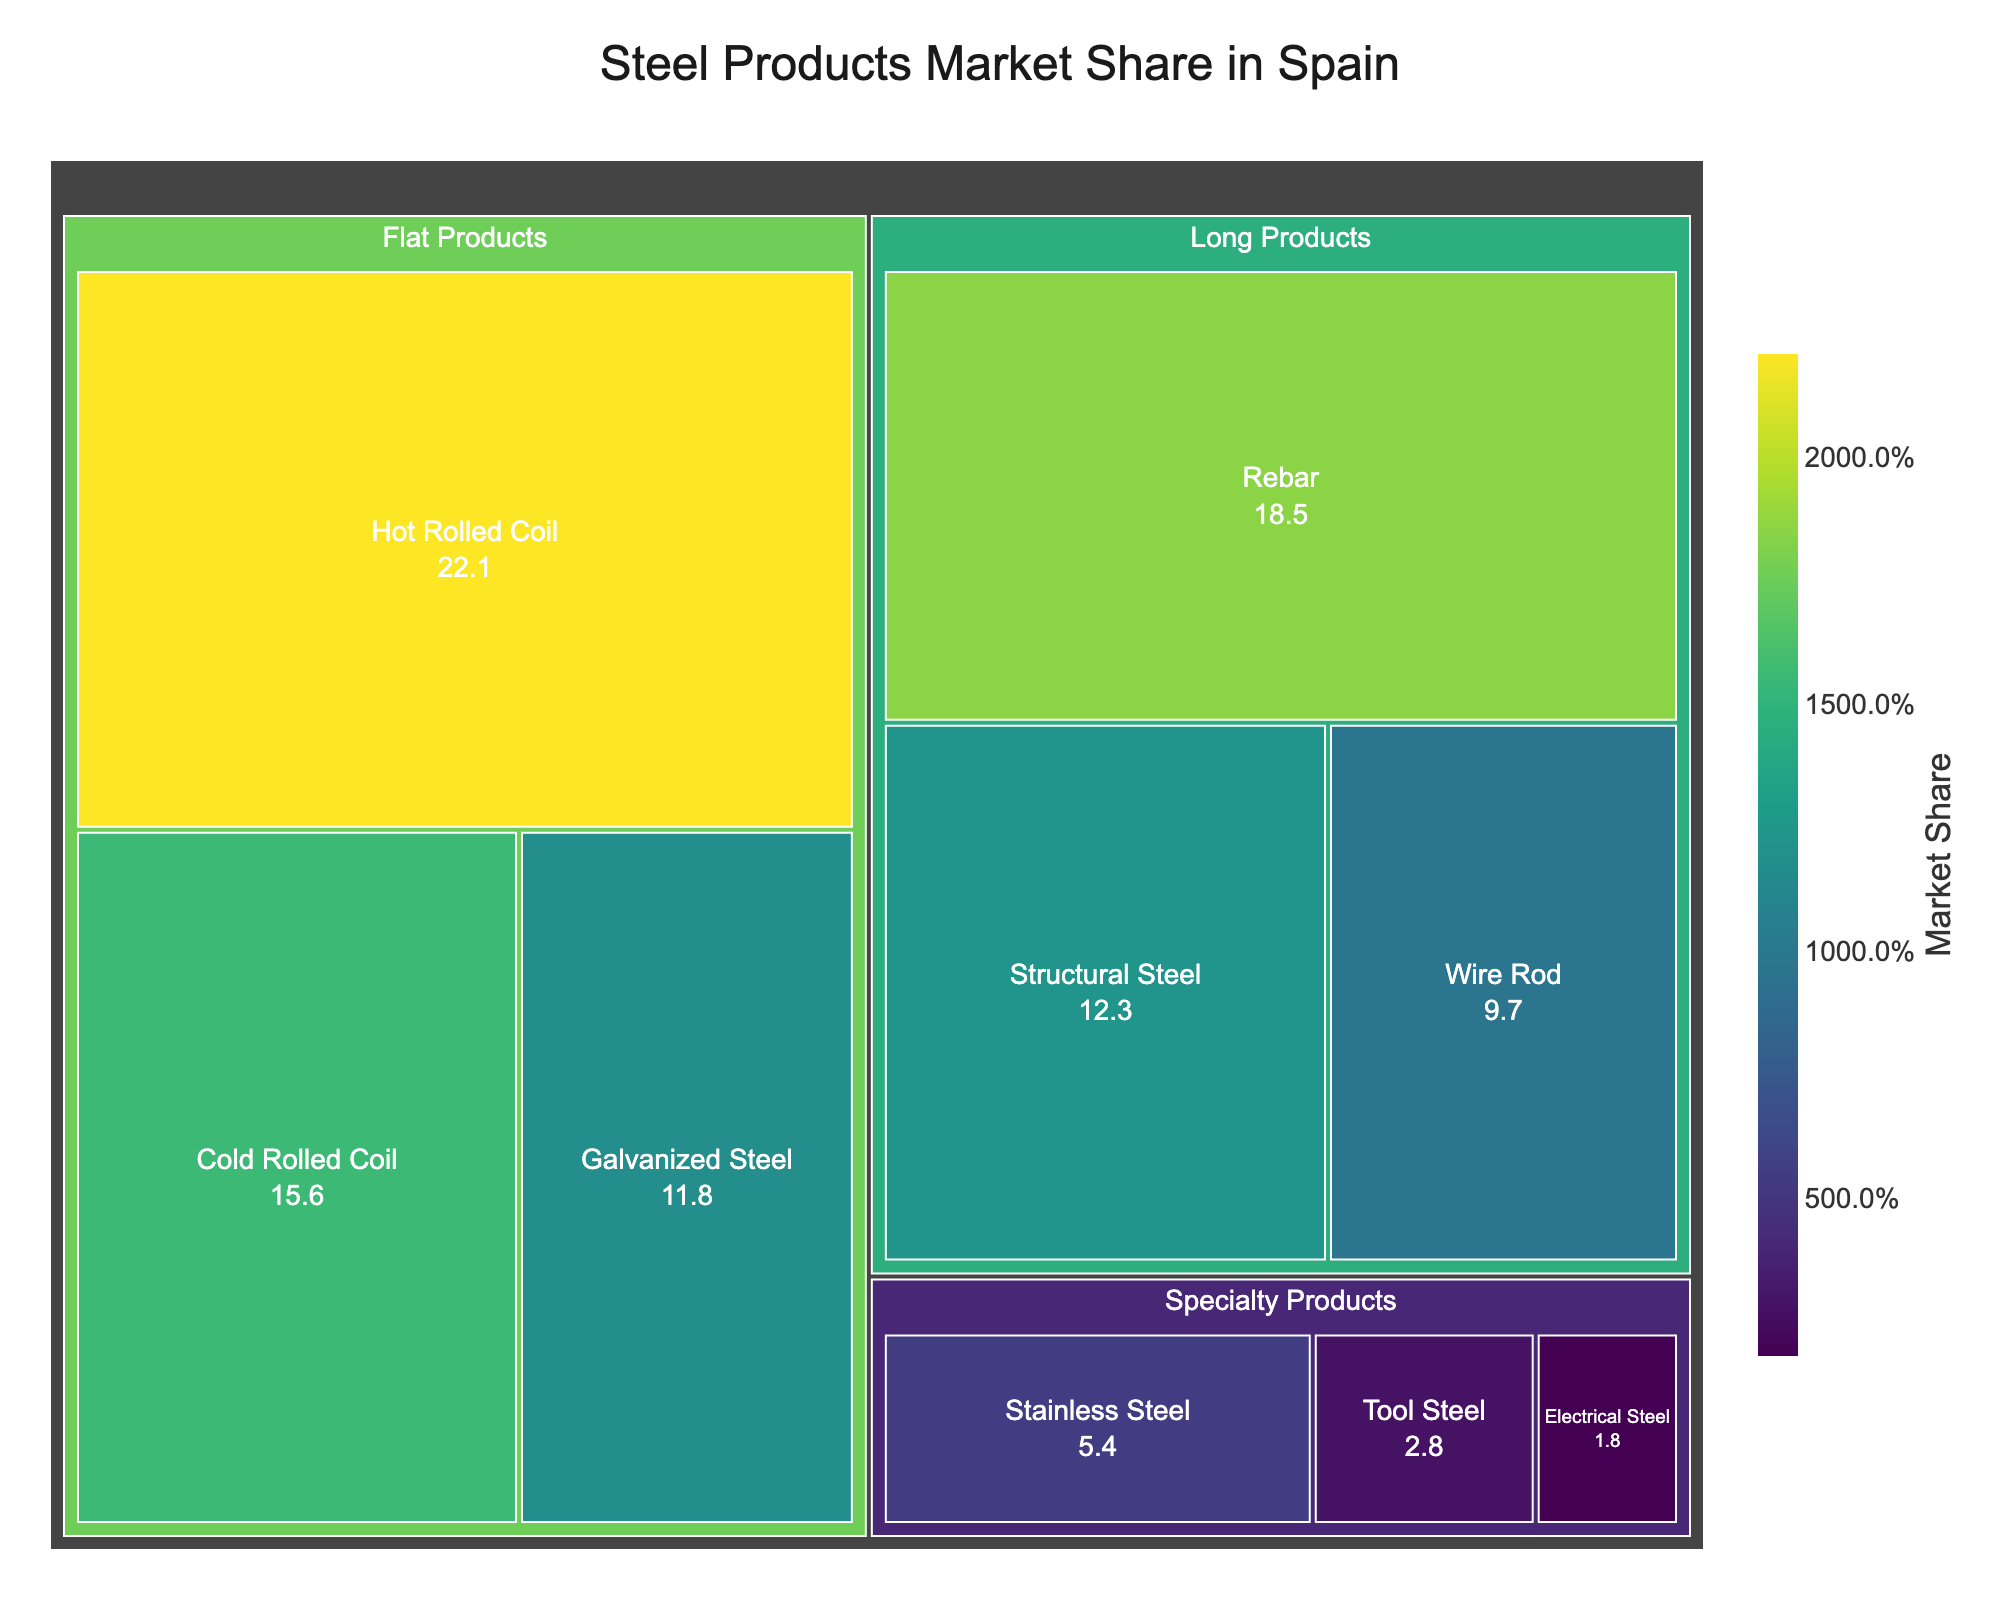Which product has the highest market share? To find this, look for the product with the largest displayed area on the treemap, which corresponds to the highest market share value.
Answer: Hot Rolled Coil What is the total market share for Long Products? Add the market share values for all products in the Long Products category: 18.5% (Rebar) + 12.3% (Structural Steel) + 9.7% (Wire Rod).
Answer: 40.5% Which category has the smallest market share? Identify the category with the smallest combined market share by looking at the areas representing each category.
Answer: Specialty Products Are Cold Rolled Coil and Galvanized Steel together greater than Hot Rolled Coil? Check the market shares of Cold Rolled Coil (15.6%) and Galvanized Steel (11.8%), and add them to compare with Hot Rolled Coil (22.1%): 15.6% + 11.8% = 27.4%, which is greater than 22.1%.
Answer: Yes Which Specialty Product has the smallest market share? Among the Specialty Products, find the product with the smallest area and market share.
Answer: Electrical Steel How does the market share of Rebar compare to Structural Steel? Compare the market share values of Rebar (18.5%) and Structural Steel (12.3%).
Answer: Rebar is higher If we combine the market shares of all Flat Products, what percentage of the total market does it represent? Add up the market share values of Flat Products: 22.1% (Hot Rolled Coil) + 15.6% (Cold Rolled Coil) + 11.8% (Galvanized Steel).
Answer: 49.5% What is the difference in market share between the largest and smallest products? Identify the product with the highest market share (Hot Rolled Coil - 22.1%) and the smallest (Electrical Steel - 1.8%), then subtract the smallest from the largest: 22.1% - 1.8%.
Answer: 20.3% Which products fall under the Flat Products category? List all the products classified under the Flat Products category as shown in the treemap.
Answer: Hot Rolled Coil, Cold Rolled Coil, Galvanized Steel What percentage of the market do Specialty Products hold as a category? Add up the market share values for all products in the Specialty Products category: 5.4% (Stainless Steel) + 2.8% (Tool Steel) + 1.8% (Electrical Steel).
Answer: 10.0% 